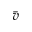<formula> <loc_0><loc_0><loc_500><loc_500>\bar { v }</formula> 